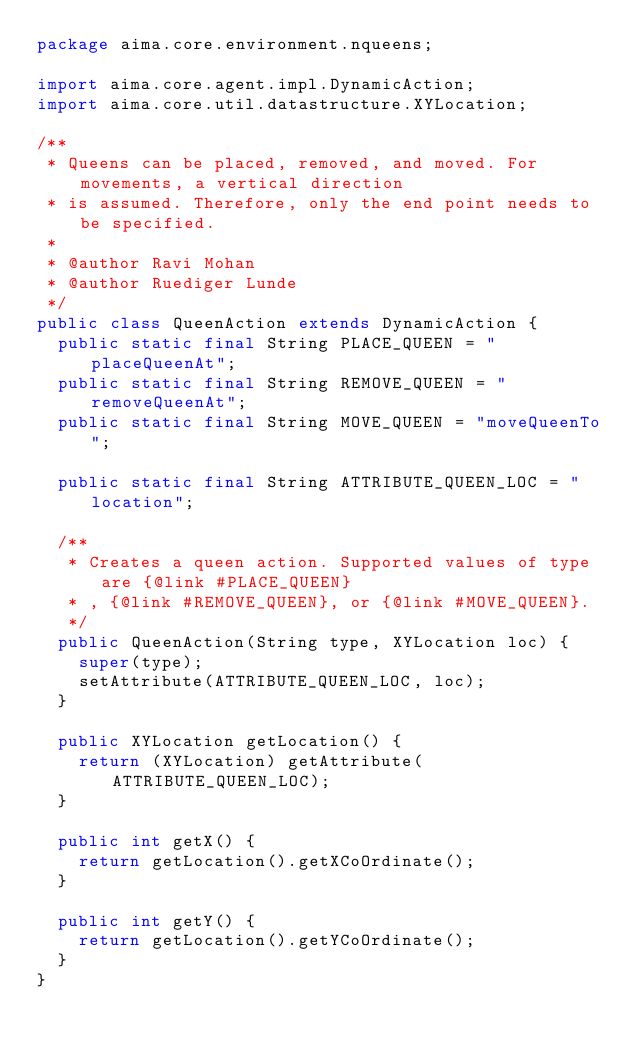Convert code to text. <code><loc_0><loc_0><loc_500><loc_500><_Java_>package aima.core.environment.nqueens;

import aima.core.agent.impl.DynamicAction;
import aima.core.util.datastructure.XYLocation;

/**
 * Queens can be placed, removed, and moved. For movements, a vertical direction
 * is assumed. Therefore, only the end point needs to be specified.
 * 
 * @author Ravi Mohan
 * @author Ruediger Lunde
 */
public class QueenAction extends DynamicAction {
	public static final String PLACE_QUEEN = "placeQueenAt";
	public static final String REMOVE_QUEEN = "removeQueenAt";
	public static final String MOVE_QUEEN = "moveQueenTo";

	public static final String ATTRIBUTE_QUEEN_LOC = "location";

	/**
	 * Creates a queen action. Supported values of type are {@link #PLACE_QUEEN}
	 * , {@link #REMOVE_QUEEN}, or {@link #MOVE_QUEEN}.
	 */
	public QueenAction(String type, XYLocation loc) {
		super(type);
		setAttribute(ATTRIBUTE_QUEEN_LOC, loc);
	}

	public XYLocation getLocation() {
		return (XYLocation) getAttribute(ATTRIBUTE_QUEEN_LOC);
	}

	public int getX() {
		return getLocation().getXCoOrdinate();
	}

	public int getY() {
		return getLocation().getYCoOrdinate();
	}
}
</code> 